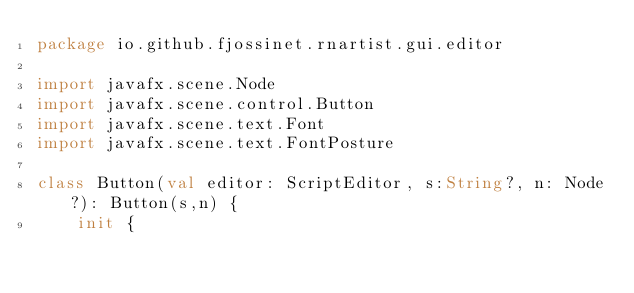<code> <loc_0><loc_0><loc_500><loc_500><_Kotlin_>package io.github.fjossinet.rnartist.gui.editor

import javafx.scene.Node
import javafx.scene.control.Button
import javafx.scene.text.Font
import javafx.scene.text.FontPosture

class Button(val editor: ScriptEditor, s:String?, n: Node?): Button(s,n) {
    init {</code> 